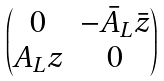<formula> <loc_0><loc_0><loc_500><loc_500>\begin{pmatrix} 0 & - \bar { A } _ { L } \bar { z } \\ A _ { L } z & 0 \end{pmatrix}</formula> 